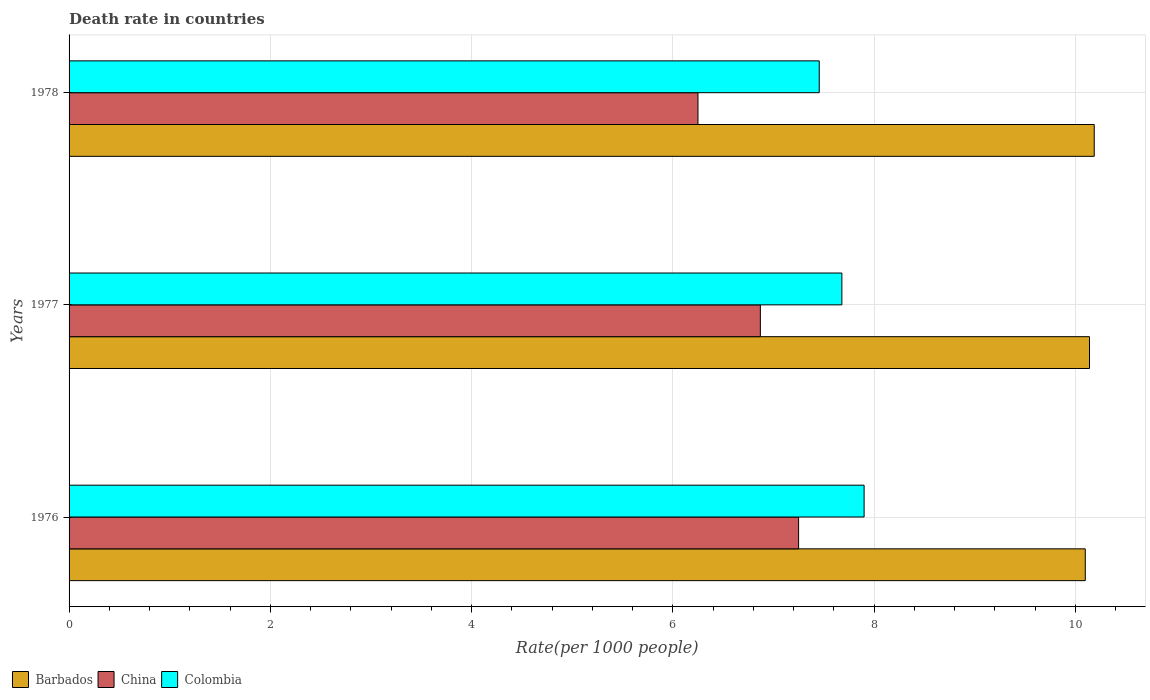How many groups of bars are there?
Make the answer very short. 3. Are the number of bars per tick equal to the number of legend labels?
Provide a succinct answer. Yes. How many bars are there on the 3rd tick from the top?
Offer a very short reply. 3. What is the label of the 1st group of bars from the top?
Offer a very short reply. 1978. What is the death rate in Colombia in 1976?
Offer a terse response. 7.9. Across all years, what is the maximum death rate in Barbados?
Make the answer very short. 10.19. Across all years, what is the minimum death rate in China?
Make the answer very short. 6.25. In which year was the death rate in Colombia maximum?
Make the answer very short. 1976. In which year was the death rate in Colombia minimum?
Offer a terse response. 1978. What is the total death rate in Colombia in the graph?
Make the answer very short. 23.04. What is the difference between the death rate in Barbados in 1977 and that in 1978?
Your answer should be compact. -0.05. What is the difference between the death rate in Barbados in 1977 and the death rate in China in 1976?
Ensure brevity in your answer.  2.89. What is the average death rate in Colombia per year?
Your response must be concise. 7.68. In the year 1978, what is the difference between the death rate in Barbados and death rate in Colombia?
Offer a very short reply. 2.73. What is the ratio of the death rate in China in 1976 to that in 1977?
Provide a short and direct response. 1.06. What is the difference between the highest and the second highest death rate in Colombia?
Offer a very short reply. 0.22. What is the difference between the highest and the lowest death rate in Barbados?
Provide a succinct answer. 0.09. What does the 3rd bar from the bottom in 1977 represents?
Give a very brief answer. Colombia. How many bars are there?
Make the answer very short. 9. What is the difference between two consecutive major ticks on the X-axis?
Offer a terse response. 2. Are the values on the major ticks of X-axis written in scientific E-notation?
Ensure brevity in your answer.  No. Does the graph contain any zero values?
Your answer should be very brief. No. How many legend labels are there?
Your answer should be very brief. 3. What is the title of the graph?
Your answer should be compact. Death rate in countries. Does "European Union" appear as one of the legend labels in the graph?
Provide a succinct answer. No. What is the label or title of the X-axis?
Give a very brief answer. Rate(per 1000 people). What is the label or title of the Y-axis?
Offer a very short reply. Years. What is the Rate(per 1000 people) in Barbados in 1976?
Offer a terse response. 10.1. What is the Rate(per 1000 people) in China in 1976?
Make the answer very short. 7.25. What is the Rate(per 1000 people) in Colombia in 1976?
Your response must be concise. 7.9. What is the Rate(per 1000 people) in Barbados in 1977?
Ensure brevity in your answer.  10.14. What is the Rate(per 1000 people) in China in 1977?
Offer a very short reply. 6.87. What is the Rate(per 1000 people) in Colombia in 1977?
Provide a succinct answer. 7.68. What is the Rate(per 1000 people) in Barbados in 1978?
Keep it short and to the point. 10.19. What is the Rate(per 1000 people) in China in 1978?
Provide a succinct answer. 6.25. What is the Rate(per 1000 people) of Colombia in 1978?
Your response must be concise. 7.46. Across all years, what is the maximum Rate(per 1000 people) in Barbados?
Keep it short and to the point. 10.19. Across all years, what is the maximum Rate(per 1000 people) of China?
Offer a very short reply. 7.25. Across all years, what is the maximum Rate(per 1000 people) of Colombia?
Your answer should be very brief. 7.9. Across all years, what is the minimum Rate(per 1000 people) in Barbados?
Make the answer very short. 10.1. Across all years, what is the minimum Rate(per 1000 people) in China?
Your response must be concise. 6.25. Across all years, what is the minimum Rate(per 1000 people) of Colombia?
Give a very brief answer. 7.46. What is the total Rate(per 1000 people) in Barbados in the graph?
Provide a short and direct response. 30.43. What is the total Rate(per 1000 people) of China in the graph?
Keep it short and to the point. 20.37. What is the total Rate(per 1000 people) in Colombia in the graph?
Your answer should be very brief. 23.04. What is the difference between the Rate(per 1000 people) of Barbados in 1976 and that in 1977?
Offer a very short reply. -0.04. What is the difference between the Rate(per 1000 people) of China in 1976 and that in 1977?
Keep it short and to the point. 0.38. What is the difference between the Rate(per 1000 people) of Colombia in 1976 and that in 1977?
Give a very brief answer. 0.22. What is the difference between the Rate(per 1000 people) in Barbados in 1976 and that in 1978?
Make the answer very short. -0.09. What is the difference between the Rate(per 1000 people) of Colombia in 1976 and that in 1978?
Your response must be concise. 0.45. What is the difference between the Rate(per 1000 people) in Barbados in 1977 and that in 1978?
Your answer should be compact. -0.05. What is the difference between the Rate(per 1000 people) in China in 1977 and that in 1978?
Provide a succinct answer. 0.62. What is the difference between the Rate(per 1000 people) in Colombia in 1977 and that in 1978?
Make the answer very short. 0.23. What is the difference between the Rate(per 1000 people) of Barbados in 1976 and the Rate(per 1000 people) of China in 1977?
Make the answer very short. 3.23. What is the difference between the Rate(per 1000 people) of Barbados in 1976 and the Rate(per 1000 people) of Colombia in 1977?
Keep it short and to the point. 2.42. What is the difference between the Rate(per 1000 people) of China in 1976 and the Rate(per 1000 people) of Colombia in 1977?
Keep it short and to the point. -0.43. What is the difference between the Rate(per 1000 people) of Barbados in 1976 and the Rate(per 1000 people) of China in 1978?
Your answer should be very brief. 3.85. What is the difference between the Rate(per 1000 people) in Barbados in 1976 and the Rate(per 1000 people) in Colombia in 1978?
Offer a terse response. 2.64. What is the difference between the Rate(per 1000 people) in China in 1976 and the Rate(per 1000 people) in Colombia in 1978?
Provide a short and direct response. -0.2. What is the difference between the Rate(per 1000 people) of Barbados in 1977 and the Rate(per 1000 people) of China in 1978?
Your answer should be compact. 3.89. What is the difference between the Rate(per 1000 people) in Barbados in 1977 and the Rate(per 1000 people) in Colombia in 1978?
Offer a very short reply. 2.69. What is the difference between the Rate(per 1000 people) in China in 1977 and the Rate(per 1000 people) in Colombia in 1978?
Provide a succinct answer. -0.58. What is the average Rate(per 1000 people) of Barbados per year?
Your answer should be very brief. 10.14. What is the average Rate(per 1000 people) of China per year?
Your response must be concise. 6.79. What is the average Rate(per 1000 people) in Colombia per year?
Your answer should be compact. 7.68. In the year 1976, what is the difference between the Rate(per 1000 people) in Barbados and Rate(per 1000 people) in China?
Provide a short and direct response. 2.85. In the year 1976, what is the difference between the Rate(per 1000 people) in Barbados and Rate(per 1000 people) in Colombia?
Ensure brevity in your answer.  2.2. In the year 1976, what is the difference between the Rate(per 1000 people) in China and Rate(per 1000 people) in Colombia?
Ensure brevity in your answer.  -0.65. In the year 1977, what is the difference between the Rate(per 1000 people) of Barbados and Rate(per 1000 people) of China?
Give a very brief answer. 3.27. In the year 1977, what is the difference between the Rate(per 1000 people) in Barbados and Rate(per 1000 people) in Colombia?
Provide a succinct answer. 2.46. In the year 1977, what is the difference between the Rate(per 1000 people) in China and Rate(per 1000 people) in Colombia?
Offer a very short reply. -0.81. In the year 1978, what is the difference between the Rate(per 1000 people) of Barbados and Rate(per 1000 people) of China?
Provide a succinct answer. 3.94. In the year 1978, what is the difference between the Rate(per 1000 people) in Barbados and Rate(per 1000 people) in Colombia?
Your response must be concise. 2.73. In the year 1978, what is the difference between the Rate(per 1000 people) of China and Rate(per 1000 people) of Colombia?
Your answer should be compact. -1.21. What is the ratio of the Rate(per 1000 people) in China in 1976 to that in 1977?
Offer a very short reply. 1.06. What is the ratio of the Rate(per 1000 people) in Colombia in 1976 to that in 1977?
Your answer should be very brief. 1.03. What is the ratio of the Rate(per 1000 people) of Barbados in 1976 to that in 1978?
Keep it short and to the point. 0.99. What is the ratio of the Rate(per 1000 people) of China in 1976 to that in 1978?
Your answer should be very brief. 1.16. What is the ratio of the Rate(per 1000 people) in Colombia in 1976 to that in 1978?
Your answer should be very brief. 1.06. What is the ratio of the Rate(per 1000 people) in Barbados in 1977 to that in 1978?
Your answer should be compact. 1. What is the ratio of the Rate(per 1000 people) of China in 1977 to that in 1978?
Keep it short and to the point. 1.1. What is the ratio of the Rate(per 1000 people) in Colombia in 1977 to that in 1978?
Your response must be concise. 1.03. What is the difference between the highest and the second highest Rate(per 1000 people) of Barbados?
Provide a short and direct response. 0.05. What is the difference between the highest and the second highest Rate(per 1000 people) of China?
Your answer should be very brief. 0.38. What is the difference between the highest and the second highest Rate(per 1000 people) in Colombia?
Ensure brevity in your answer.  0.22. What is the difference between the highest and the lowest Rate(per 1000 people) in Barbados?
Provide a succinct answer. 0.09. What is the difference between the highest and the lowest Rate(per 1000 people) in China?
Offer a terse response. 1. What is the difference between the highest and the lowest Rate(per 1000 people) of Colombia?
Ensure brevity in your answer.  0.45. 